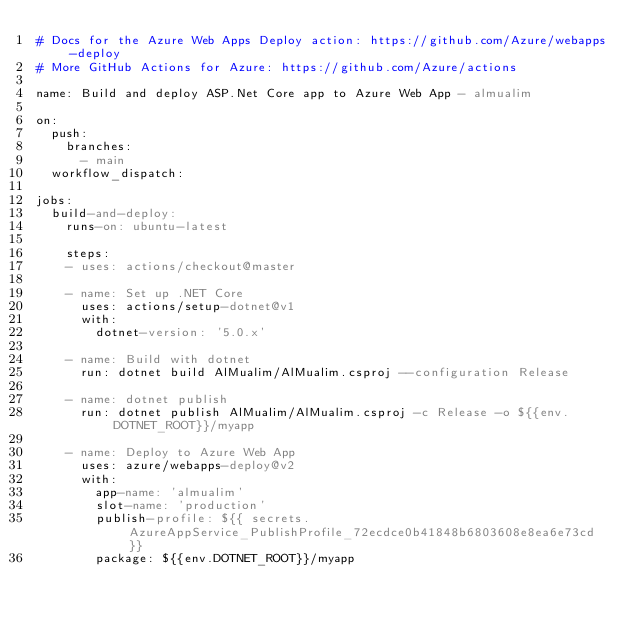<code> <loc_0><loc_0><loc_500><loc_500><_YAML_># Docs for the Azure Web Apps Deploy action: https://github.com/Azure/webapps-deploy
# More GitHub Actions for Azure: https://github.com/Azure/actions

name: Build and deploy ASP.Net Core app to Azure Web App - almualim

on:
  push:
    branches:
      - main
  workflow_dispatch:

jobs:
  build-and-deploy:
    runs-on: ubuntu-latest

    steps:
    - uses: actions/checkout@master

    - name: Set up .NET Core
      uses: actions/setup-dotnet@v1
      with:
        dotnet-version: '5.0.x'

    - name: Build with dotnet
      run: dotnet build AlMualim/AlMualim.csproj --configuration Release

    - name: dotnet publish
      run: dotnet publish AlMualim/AlMualim.csproj -c Release -o ${{env.DOTNET_ROOT}}/myapp

    - name: Deploy to Azure Web App
      uses: azure/webapps-deploy@v2
      with:
        app-name: 'almualim'
        slot-name: 'production'
        publish-profile: ${{ secrets.AzureAppService_PublishProfile_72ecdce0b41848b6803608e8ea6e73cd }}
        package: ${{env.DOTNET_ROOT}}/myapp </code> 